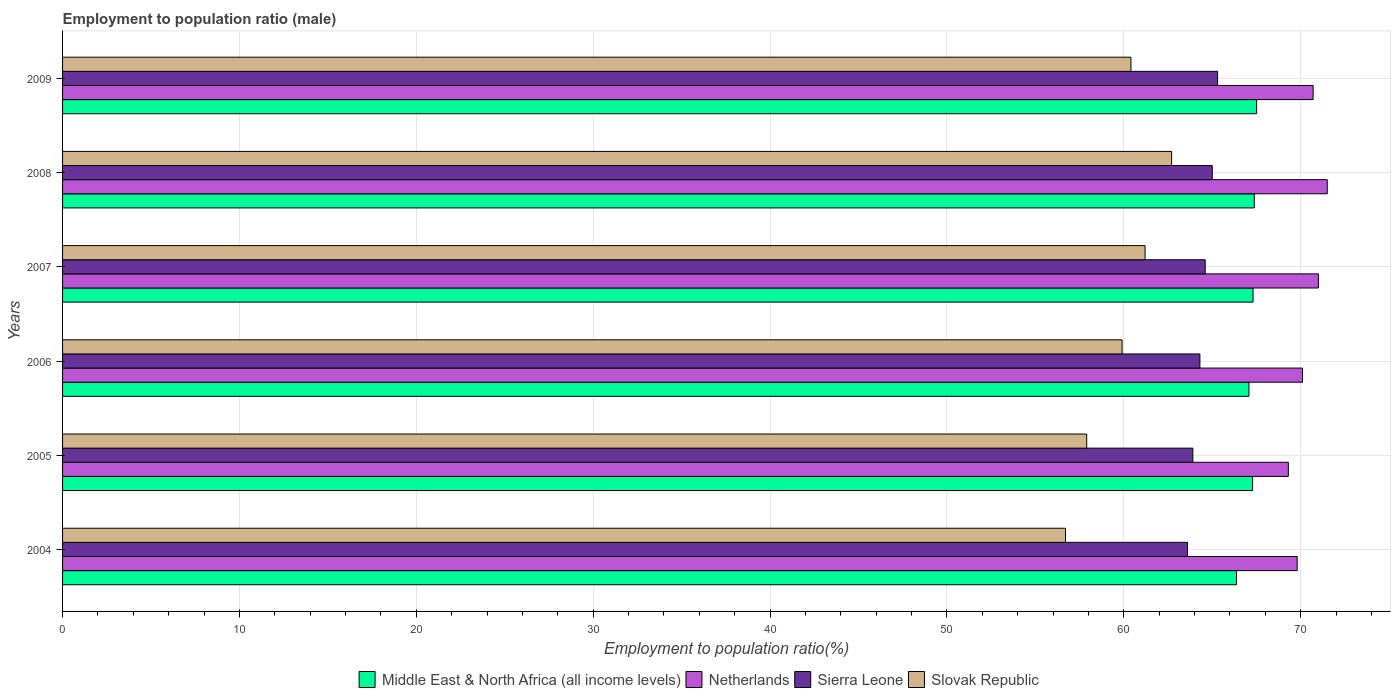How many groups of bars are there?
Offer a very short reply. 6. Are the number of bars on each tick of the Y-axis equal?
Your answer should be very brief. Yes. How many bars are there on the 2nd tick from the bottom?
Provide a short and direct response. 4. What is the label of the 6th group of bars from the top?
Give a very brief answer. 2004. What is the employment to population ratio in Middle East & North Africa (all income levels) in 2009?
Provide a succinct answer. 67.51. Across all years, what is the maximum employment to population ratio in Middle East & North Africa (all income levels)?
Your answer should be compact. 67.51. Across all years, what is the minimum employment to population ratio in Netherlands?
Offer a very short reply. 69.3. In which year was the employment to population ratio in Netherlands maximum?
Offer a very short reply. 2008. What is the total employment to population ratio in Slovak Republic in the graph?
Provide a short and direct response. 358.8. What is the difference between the employment to population ratio in Netherlands in 2005 and that in 2008?
Provide a short and direct response. -2.2. What is the difference between the employment to population ratio in Netherlands in 2009 and the employment to population ratio in Slovak Republic in 2008?
Make the answer very short. 8. What is the average employment to population ratio in Netherlands per year?
Ensure brevity in your answer.  70.4. In the year 2005, what is the difference between the employment to population ratio in Slovak Republic and employment to population ratio in Sierra Leone?
Offer a very short reply. -6. In how many years, is the employment to population ratio in Slovak Republic greater than 70 %?
Offer a very short reply. 0. What is the ratio of the employment to population ratio in Slovak Republic in 2005 to that in 2008?
Provide a short and direct response. 0.92. Is the difference between the employment to population ratio in Slovak Republic in 2007 and 2008 greater than the difference between the employment to population ratio in Sierra Leone in 2007 and 2008?
Give a very brief answer. No. What is the difference between the highest and the second highest employment to population ratio in Sierra Leone?
Your answer should be compact. 0.3. What is the difference between the highest and the lowest employment to population ratio in Slovak Republic?
Provide a succinct answer. 6. What does the 1st bar from the bottom in 2009 represents?
Give a very brief answer. Middle East & North Africa (all income levels). How many years are there in the graph?
Ensure brevity in your answer.  6. What is the difference between two consecutive major ticks on the X-axis?
Your answer should be very brief. 10. Are the values on the major ticks of X-axis written in scientific E-notation?
Your answer should be compact. No. Where does the legend appear in the graph?
Your answer should be compact. Bottom center. How are the legend labels stacked?
Your answer should be very brief. Horizontal. What is the title of the graph?
Ensure brevity in your answer.  Employment to population ratio (male). Does "South Asia" appear as one of the legend labels in the graph?
Your answer should be compact. No. What is the label or title of the X-axis?
Give a very brief answer. Employment to population ratio(%). What is the label or title of the Y-axis?
Provide a short and direct response. Years. What is the Employment to population ratio(%) in Middle East & North Africa (all income levels) in 2004?
Ensure brevity in your answer.  66.37. What is the Employment to population ratio(%) of Netherlands in 2004?
Your answer should be very brief. 69.8. What is the Employment to population ratio(%) in Sierra Leone in 2004?
Provide a succinct answer. 63.6. What is the Employment to population ratio(%) of Slovak Republic in 2004?
Give a very brief answer. 56.7. What is the Employment to population ratio(%) in Middle East & North Africa (all income levels) in 2005?
Ensure brevity in your answer.  67.28. What is the Employment to population ratio(%) in Netherlands in 2005?
Keep it short and to the point. 69.3. What is the Employment to population ratio(%) of Sierra Leone in 2005?
Your answer should be very brief. 63.9. What is the Employment to population ratio(%) in Slovak Republic in 2005?
Your answer should be compact. 57.9. What is the Employment to population ratio(%) in Middle East & North Africa (all income levels) in 2006?
Your answer should be very brief. 67.07. What is the Employment to population ratio(%) of Netherlands in 2006?
Offer a terse response. 70.1. What is the Employment to population ratio(%) in Sierra Leone in 2006?
Your answer should be very brief. 64.3. What is the Employment to population ratio(%) of Slovak Republic in 2006?
Ensure brevity in your answer.  59.9. What is the Employment to population ratio(%) in Middle East & North Africa (all income levels) in 2007?
Provide a short and direct response. 67.3. What is the Employment to population ratio(%) of Sierra Leone in 2007?
Your answer should be compact. 64.6. What is the Employment to population ratio(%) of Slovak Republic in 2007?
Provide a short and direct response. 61.2. What is the Employment to population ratio(%) in Middle East & North Africa (all income levels) in 2008?
Your answer should be compact. 67.37. What is the Employment to population ratio(%) of Netherlands in 2008?
Offer a very short reply. 71.5. What is the Employment to population ratio(%) in Sierra Leone in 2008?
Your response must be concise. 65. What is the Employment to population ratio(%) of Slovak Republic in 2008?
Your answer should be very brief. 62.7. What is the Employment to population ratio(%) of Middle East & North Africa (all income levels) in 2009?
Give a very brief answer. 67.51. What is the Employment to population ratio(%) of Netherlands in 2009?
Give a very brief answer. 70.7. What is the Employment to population ratio(%) of Sierra Leone in 2009?
Keep it short and to the point. 65.3. What is the Employment to population ratio(%) of Slovak Republic in 2009?
Provide a short and direct response. 60.4. Across all years, what is the maximum Employment to population ratio(%) of Middle East & North Africa (all income levels)?
Your answer should be compact. 67.51. Across all years, what is the maximum Employment to population ratio(%) of Netherlands?
Your response must be concise. 71.5. Across all years, what is the maximum Employment to population ratio(%) of Sierra Leone?
Ensure brevity in your answer.  65.3. Across all years, what is the maximum Employment to population ratio(%) of Slovak Republic?
Your answer should be very brief. 62.7. Across all years, what is the minimum Employment to population ratio(%) of Middle East & North Africa (all income levels)?
Keep it short and to the point. 66.37. Across all years, what is the minimum Employment to population ratio(%) in Netherlands?
Make the answer very short. 69.3. Across all years, what is the minimum Employment to population ratio(%) of Sierra Leone?
Your answer should be very brief. 63.6. Across all years, what is the minimum Employment to population ratio(%) in Slovak Republic?
Provide a succinct answer. 56.7. What is the total Employment to population ratio(%) in Middle East & North Africa (all income levels) in the graph?
Offer a terse response. 402.9. What is the total Employment to population ratio(%) in Netherlands in the graph?
Make the answer very short. 422.4. What is the total Employment to population ratio(%) in Sierra Leone in the graph?
Your response must be concise. 386.7. What is the total Employment to population ratio(%) in Slovak Republic in the graph?
Make the answer very short. 358.8. What is the difference between the Employment to population ratio(%) of Middle East & North Africa (all income levels) in 2004 and that in 2005?
Keep it short and to the point. -0.91. What is the difference between the Employment to population ratio(%) in Sierra Leone in 2004 and that in 2005?
Give a very brief answer. -0.3. What is the difference between the Employment to population ratio(%) in Middle East & North Africa (all income levels) in 2004 and that in 2006?
Offer a terse response. -0.71. What is the difference between the Employment to population ratio(%) of Netherlands in 2004 and that in 2006?
Give a very brief answer. -0.3. What is the difference between the Employment to population ratio(%) of Sierra Leone in 2004 and that in 2006?
Offer a terse response. -0.7. What is the difference between the Employment to population ratio(%) in Slovak Republic in 2004 and that in 2006?
Your answer should be compact. -3.2. What is the difference between the Employment to population ratio(%) of Middle East & North Africa (all income levels) in 2004 and that in 2007?
Give a very brief answer. -0.94. What is the difference between the Employment to population ratio(%) of Netherlands in 2004 and that in 2007?
Your response must be concise. -1.2. What is the difference between the Employment to population ratio(%) in Slovak Republic in 2004 and that in 2007?
Give a very brief answer. -4.5. What is the difference between the Employment to population ratio(%) in Middle East & North Africa (all income levels) in 2004 and that in 2008?
Offer a terse response. -1.01. What is the difference between the Employment to population ratio(%) of Netherlands in 2004 and that in 2008?
Offer a terse response. -1.7. What is the difference between the Employment to population ratio(%) of Sierra Leone in 2004 and that in 2008?
Give a very brief answer. -1.4. What is the difference between the Employment to population ratio(%) in Slovak Republic in 2004 and that in 2008?
Offer a terse response. -6. What is the difference between the Employment to population ratio(%) of Middle East & North Africa (all income levels) in 2004 and that in 2009?
Provide a short and direct response. -1.14. What is the difference between the Employment to population ratio(%) in Netherlands in 2004 and that in 2009?
Your response must be concise. -0.9. What is the difference between the Employment to population ratio(%) in Sierra Leone in 2004 and that in 2009?
Your response must be concise. -1.7. What is the difference between the Employment to population ratio(%) of Middle East & North Africa (all income levels) in 2005 and that in 2006?
Provide a short and direct response. 0.21. What is the difference between the Employment to population ratio(%) in Middle East & North Africa (all income levels) in 2005 and that in 2007?
Give a very brief answer. -0.03. What is the difference between the Employment to population ratio(%) of Slovak Republic in 2005 and that in 2007?
Offer a very short reply. -3.3. What is the difference between the Employment to population ratio(%) of Middle East & North Africa (all income levels) in 2005 and that in 2008?
Provide a succinct answer. -0.09. What is the difference between the Employment to population ratio(%) in Netherlands in 2005 and that in 2008?
Provide a short and direct response. -2.2. What is the difference between the Employment to population ratio(%) of Middle East & North Africa (all income levels) in 2005 and that in 2009?
Your response must be concise. -0.23. What is the difference between the Employment to population ratio(%) of Netherlands in 2005 and that in 2009?
Give a very brief answer. -1.4. What is the difference between the Employment to population ratio(%) in Middle East & North Africa (all income levels) in 2006 and that in 2007?
Your answer should be compact. -0.23. What is the difference between the Employment to population ratio(%) of Middle East & North Africa (all income levels) in 2006 and that in 2008?
Offer a terse response. -0.3. What is the difference between the Employment to population ratio(%) in Sierra Leone in 2006 and that in 2008?
Provide a short and direct response. -0.7. What is the difference between the Employment to population ratio(%) in Middle East & North Africa (all income levels) in 2006 and that in 2009?
Make the answer very short. -0.43. What is the difference between the Employment to population ratio(%) of Netherlands in 2006 and that in 2009?
Keep it short and to the point. -0.6. What is the difference between the Employment to population ratio(%) in Sierra Leone in 2006 and that in 2009?
Your answer should be compact. -1. What is the difference between the Employment to population ratio(%) in Middle East & North Africa (all income levels) in 2007 and that in 2008?
Offer a terse response. -0.07. What is the difference between the Employment to population ratio(%) in Sierra Leone in 2007 and that in 2008?
Your response must be concise. -0.4. What is the difference between the Employment to population ratio(%) in Slovak Republic in 2007 and that in 2008?
Keep it short and to the point. -1.5. What is the difference between the Employment to population ratio(%) of Middle East & North Africa (all income levels) in 2007 and that in 2009?
Your answer should be very brief. -0.2. What is the difference between the Employment to population ratio(%) in Netherlands in 2007 and that in 2009?
Provide a short and direct response. 0.3. What is the difference between the Employment to population ratio(%) of Sierra Leone in 2007 and that in 2009?
Provide a short and direct response. -0.7. What is the difference between the Employment to population ratio(%) in Slovak Republic in 2007 and that in 2009?
Provide a succinct answer. 0.8. What is the difference between the Employment to population ratio(%) of Middle East & North Africa (all income levels) in 2008 and that in 2009?
Keep it short and to the point. -0.13. What is the difference between the Employment to population ratio(%) in Middle East & North Africa (all income levels) in 2004 and the Employment to population ratio(%) in Netherlands in 2005?
Provide a succinct answer. -2.93. What is the difference between the Employment to population ratio(%) in Middle East & North Africa (all income levels) in 2004 and the Employment to population ratio(%) in Sierra Leone in 2005?
Your answer should be compact. 2.47. What is the difference between the Employment to population ratio(%) in Middle East & North Africa (all income levels) in 2004 and the Employment to population ratio(%) in Slovak Republic in 2005?
Provide a succinct answer. 8.47. What is the difference between the Employment to population ratio(%) in Netherlands in 2004 and the Employment to population ratio(%) in Sierra Leone in 2005?
Offer a very short reply. 5.9. What is the difference between the Employment to population ratio(%) of Netherlands in 2004 and the Employment to population ratio(%) of Slovak Republic in 2005?
Keep it short and to the point. 11.9. What is the difference between the Employment to population ratio(%) in Sierra Leone in 2004 and the Employment to population ratio(%) in Slovak Republic in 2005?
Make the answer very short. 5.7. What is the difference between the Employment to population ratio(%) of Middle East & North Africa (all income levels) in 2004 and the Employment to population ratio(%) of Netherlands in 2006?
Offer a terse response. -3.73. What is the difference between the Employment to population ratio(%) of Middle East & North Africa (all income levels) in 2004 and the Employment to population ratio(%) of Sierra Leone in 2006?
Keep it short and to the point. 2.07. What is the difference between the Employment to population ratio(%) of Middle East & North Africa (all income levels) in 2004 and the Employment to population ratio(%) of Slovak Republic in 2006?
Your answer should be very brief. 6.47. What is the difference between the Employment to population ratio(%) of Netherlands in 2004 and the Employment to population ratio(%) of Sierra Leone in 2006?
Your answer should be compact. 5.5. What is the difference between the Employment to population ratio(%) in Middle East & North Africa (all income levels) in 2004 and the Employment to population ratio(%) in Netherlands in 2007?
Keep it short and to the point. -4.63. What is the difference between the Employment to population ratio(%) of Middle East & North Africa (all income levels) in 2004 and the Employment to population ratio(%) of Sierra Leone in 2007?
Provide a succinct answer. 1.77. What is the difference between the Employment to population ratio(%) of Middle East & North Africa (all income levels) in 2004 and the Employment to population ratio(%) of Slovak Republic in 2007?
Ensure brevity in your answer.  5.17. What is the difference between the Employment to population ratio(%) of Sierra Leone in 2004 and the Employment to population ratio(%) of Slovak Republic in 2007?
Make the answer very short. 2.4. What is the difference between the Employment to population ratio(%) of Middle East & North Africa (all income levels) in 2004 and the Employment to population ratio(%) of Netherlands in 2008?
Make the answer very short. -5.13. What is the difference between the Employment to population ratio(%) of Middle East & North Africa (all income levels) in 2004 and the Employment to population ratio(%) of Sierra Leone in 2008?
Provide a succinct answer. 1.37. What is the difference between the Employment to population ratio(%) in Middle East & North Africa (all income levels) in 2004 and the Employment to population ratio(%) in Slovak Republic in 2008?
Ensure brevity in your answer.  3.67. What is the difference between the Employment to population ratio(%) of Sierra Leone in 2004 and the Employment to population ratio(%) of Slovak Republic in 2008?
Your answer should be compact. 0.9. What is the difference between the Employment to population ratio(%) of Middle East & North Africa (all income levels) in 2004 and the Employment to population ratio(%) of Netherlands in 2009?
Keep it short and to the point. -4.33. What is the difference between the Employment to population ratio(%) of Middle East & North Africa (all income levels) in 2004 and the Employment to population ratio(%) of Sierra Leone in 2009?
Offer a very short reply. 1.07. What is the difference between the Employment to population ratio(%) in Middle East & North Africa (all income levels) in 2004 and the Employment to population ratio(%) in Slovak Republic in 2009?
Offer a very short reply. 5.97. What is the difference between the Employment to population ratio(%) in Netherlands in 2004 and the Employment to population ratio(%) in Sierra Leone in 2009?
Your answer should be very brief. 4.5. What is the difference between the Employment to population ratio(%) in Middle East & North Africa (all income levels) in 2005 and the Employment to population ratio(%) in Netherlands in 2006?
Provide a succinct answer. -2.82. What is the difference between the Employment to population ratio(%) of Middle East & North Africa (all income levels) in 2005 and the Employment to population ratio(%) of Sierra Leone in 2006?
Offer a very short reply. 2.98. What is the difference between the Employment to population ratio(%) in Middle East & North Africa (all income levels) in 2005 and the Employment to population ratio(%) in Slovak Republic in 2006?
Provide a succinct answer. 7.38. What is the difference between the Employment to population ratio(%) of Middle East & North Africa (all income levels) in 2005 and the Employment to population ratio(%) of Netherlands in 2007?
Your response must be concise. -3.72. What is the difference between the Employment to population ratio(%) in Middle East & North Africa (all income levels) in 2005 and the Employment to population ratio(%) in Sierra Leone in 2007?
Give a very brief answer. 2.68. What is the difference between the Employment to population ratio(%) of Middle East & North Africa (all income levels) in 2005 and the Employment to population ratio(%) of Slovak Republic in 2007?
Provide a short and direct response. 6.08. What is the difference between the Employment to population ratio(%) in Netherlands in 2005 and the Employment to population ratio(%) in Slovak Republic in 2007?
Your answer should be very brief. 8.1. What is the difference between the Employment to population ratio(%) of Middle East & North Africa (all income levels) in 2005 and the Employment to population ratio(%) of Netherlands in 2008?
Your response must be concise. -4.22. What is the difference between the Employment to population ratio(%) of Middle East & North Africa (all income levels) in 2005 and the Employment to population ratio(%) of Sierra Leone in 2008?
Give a very brief answer. 2.28. What is the difference between the Employment to population ratio(%) of Middle East & North Africa (all income levels) in 2005 and the Employment to population ratio(%) of Slovak Republic in 2008?
Provide a succinct answer. 4.58. What is the difference between the Employment to population ratio(%) in Sierra Leone in 2005 and the Employment to population ratio(%) in Slovak Republic in 2008?
Offer a terse response. 1.2. What is the difference between the Employment to population ratio(%) in Middle East & North Africa (all income levels) in 2005 and the Employment to population ratio(%) in Netherlands in 2009?
Your answer should be compact. -3.42. What is the difference between the Employment to population ratio(%) in Middle East & North Africa (all income levels) in 2005 and the Employment to population ratio(%) in Sierra Leone in 2009?
Your response must be concise. 1.98. What is the difference between the Employment to population ratio(%) of Middle East & North Africa (all income levels) in 2005 and the Employment to population ratio(%) of Slovak Republic in 2009?
Give a very brief answer. 6.88. What is the difference between the Employment to population ratio(%) in Netherlands in 2005 and the Employment to population ratio(%) in Sierra Leone in 2009?
Your answer should be very brief. 4. What is the difference between the Employment to population ratio(%) in Middle East & North Africa (all income levels) in 2006 and the Employment to population ratio(%) in Netherlands in 2007?
Make the answer very short. -3.93. What is the difference between the Employment to population ratio(%) in Middle East & North Africa (all income levels) in 2006 and the Employment to population ratio(%) in Sierra Leone in 2007?
Provide a succinct answer. 2.47. What is the difference between the Employment to population ratio(%) in Middle East & North Africa (all income levels) in 2006 and the Employment to population ratio(%) in Slovak Republic in 2007?
Provide a short and direct response. 5.87. What is the difference between the Employment to population ratio(%) of Netherlands in 2006 and the Employment to population ratio(%) of Slovak Republic in 2007?
Your answer should be very brief. 8.9. What is the difference between the Employment to population ratio(%) in Sierra Leone in 2006 and the Employment to population ratio(%) in Slovak Republic in 2007?
Make the answer very short. 3.1. What is the difference between the Employment to population ratio(%) of Middle East & North Africa (all income levels) in 2006 and the Employment to population ratio(%) of Netherlands in 2008?
Give a very brief answer. -4.43. What is the difference between the Employment to population ratio(%) of Middle East & North Africa (all income levels) in 2006 and the Employment to population ratio(%) of Sierra Leone in 2008?
Provide a succinct answer. 2.07. What is the difference between the Employment to population ratio(%) of Middle East & North Africa (all income levels) in 2006 and the Employment to population ratio(%) of Slovak Republic in 2008?
Provide a short and direct response. 4.37. What is the difference between the Employment to population ratio(%) in Netherlands in 2006 and the Employment to population ratio(%) in Slovak Republic in 2008?
Your response must be concise. 7.4. What is the difference between the Employment to population ratio(%) in Middle East & North Africa (all income levels) in 2006 and the Employment to population ratio(%) in Netherlands in 2009?
Give a very brief answer. -3.63. What is the difference between the Employment to population ratio(%) in Middle East & North Africa (all income levels) in 2006 and the Employment to population ratio(%) in Sierra Leone in 2009?
Give a very brief answer. 1.77. What is the difference between the Employment to population ratio(%) in Middle East & North Africa (all income levels) in 2006 and the Employment to population ratio(%) in Slovak Republic in 2009?
Offer a very short reply. 6.67. What is the difference between the Employment to population ratio(%) in Netherlands in 2006 and the Employment to population ratio(%) in Sierra Leone in 2009?
Make the answer very short. 4.8. What is the difference between the Employment to population ratio(%) of Middle East & North Africa (all income levels) in 2007 and the Employment to population ratio(%) of Netherlands in 2008?
Ensure brevity in your answer.  -4.2. What is the difference between the Employment to population ratio(%) in Middle East & North Africa (all income levels) in 2007 and the Employment to population ratio(%) in Sierra Leone in 2008?
Offer a very short reply. 2.3. What is the difference between the Employment to population ratio(%) of Middle East & North Africa (all income levels) in 2007 and the Employment to population ratio(%) of Slovak Republic in 2008?
Provide a succinct answer. 4.6. What is the difference between the Employment to population ratio(%) of Sierra Leone in 2007 and the Employment to population ratio(%) of Slovak Republic in 2008?
Give a very brief answer. 1.9. What is the difference between the Employment to population ratio(%) of Middle East & North Africa (all income levels) in 2007 and the Employment to population ratio(%) of Netherlands in 2009?
Your answer should be compact. -3.4. What is the difference between the Employment to population ratio(%) in Middle East & North Africa (all income levels) in 2007 and the Employment to population ratio(%) in Sierra Leone in 2009?
Your response must be concise. 2. What is the difference between the Employment to population ratio(%) of Middle East & North Africa (all income levels) in 2007 and the Employment to population ratio(%) of Slovak Republic in 2009?
Your answer should be very brief. 6.9. What is the difference between the Employment to population ratio(%) in Netherlands in 2007 and the Employment to population ratio(%) in Sierra Leone in 2009?
Offer a very short reply. 5.7. What is the difference between the Employment to population ratio(%) in Netherlands in 2007 and the Employment to population ratio(%) in Slovak Republic in 2009?
Give a very brief answer. 10.6. What is the difference between the Employment to population ratio(%) in Middle East & North Africa (all income levels) in 2008 and the Employment to population ratio(%) in Netherlands in 2009?
Ensure brevity in your answer.  -3.33. What is the difference between the Employment to population ratio(%) of Middle East & North Africa (all income levels) in 2008 and the Employment to population ratio(%) of Sierra Leone in 2009?
Keep it short and to the point. 2.07. What is the difference between the Employment to population ratio(%) in Middle East & North Africa (all income levels) in 2008 and the Employment to population ratio(%) in Slovak Republic in 2009?
Keep it short and to the point. 6.97. What is the difference between the Employment to population ratio(%) of Netherlands in 2008 and the Employment to population ratio(%) of Slovak Republic in 2009?
Provide a succinct answer. 11.1. What is the difference between the Employment to population ratio(%) in Sierra Leone in 2008 and the Employment to population ratio(%) in Slovak Republic in 2009?
Offer a very short reply. 4.6. What is the average Employment to population ratio(%) of Middle East & North Africa (all income levels) per year?
Offer a terse response. 67.15. What is the average Employment to population ratio(%) of Netherlands per year?
Give a very brief answer. 70.4. What is the average Employment to population ratio(%) in Sierra Leone per year?
Your response must be concise. 64.45. What is the average Employment to population ratio(%) in Slovak Republic per year?
Offer a very short reply. 59.8. In the year 2004, what is the difference between the Employment to population ratio(%) of Middle East & North Africa (all income levels) and Employment to population ratio(%) of Netherlands?
Your response must be concise. -3.43. In the year 2004, what is the difference between the Employment to population ratio(%) in Middle East & North Africa (all income levels) and Employment to population ratio(%) in Sierra Leone?
Your answer should be very brief. 2.77. In the year 2004, what is the difference between the Employment to population ratio(%) of Middle East & North Africa (all income levels) and Employment to population ratio(%) of Slovak Republic?
Your response must be concise. 9.67. In the year 2004, what is the difference between the Employment to population ratio(%) of Netherlands and Employment to population ratio(%) of Slovak Republic?
Give a very brief answer. 13.1. In the year 2005, what is the difference between the Employment to population ratio(%) of Middle East & North Africa (all income levels) and Employment to population ratio(%) of Netherlands?
Your response must be concise. -2.02. In the year 2005, what is the difference between the Employment to population ratio(%) of Middle East & North Africa (all income levels) and Employment to population ratio(%) of Sierra Leone?
Your answer should be compact. 3.38. In the year 2005, what is the difference between the Employment to population ratio(%) of Middle East & North Africa (all income levels) and Employment to population ratio(%) of Slovak Republic?
Give a very brief answer. 9.38. In the year 2005, what is the difference between the Employment to population ratio(%) of Netherlands and Employment to population ratio(%) of Sierra Leone?
Provide a short and direct response. 5.4. In the year 2005, what is the difference between the Employment to population ratio(%) of Sierra Leone and Employment to population ratio(%) of Slovak Republic?
Offer a terse response. 6. In the year 2006, what is the difference between the Employment to population ratio(%) of Middle East & North Africa (all income levels) and Employment to population ratio(%) of Netherlands?
Your response must be concise. -3.03. In the year 2006, what is the difference between the Employment to population ratio(%) of Middle East & North Africa (all income levels) and Employment to population ratio(%) of Sierra Leone?
Provide a short and direct response. 2.77. In the year 2006, what is the difference between the Employment to population ratio(%) in Middle East & North Africa (all income levels) and Employment to population ratio(%) in Slovak Republic?
Provide a short and direct response. 7.17. In the year 2006, what is the difference between the Employment to population ratio(%) in Netherlands and Employment to population ratio(%) in Slovak Republic?
Keep it short and to the point. 10.2. In the year 2007, what is the difference between the Employment to population ratio(%) in Middle East & North Africa (all income levels) and Employment to population ratio(%) in Netherlands?
Provide a short and direct response. -3.7. In the year 2007, what is the difference between the Employment to population ratio(%) in Middle East & North Africa (all income levels) and Employment to population ratio(%) in Sierra Leone?
Your answer should be very brief. 2.7. In the year 2007, what is the difference between the Employment to population ratio(%) of Middle East & North Africa (all income levels) and Employment to population ratio(%) of Slovak Republic?
Make the answer very short. 6.1. In the year 2007, what is the difference between the Employment to population ratio(%) of Netherlands and Employment to population ratio(%) of Sierra Leone?
Offer a very short reply. 6.4. In the year 2007, what is the difference between the Employment to population ratio(%) of Netherlands and Employment to population ratio(%) of Slovak Republic?
Your answer should be compact. 9.8. In the year 2007, what is the difference between the Employment to population ratio(%) in Sierra Leone and Employment to population ratio(%) in Slovak Republic?
Provide a succinct answer. 3.4. In the year 2008, what is the difference between the Employment to population ratio(%) in Middle East & North Africa (all income levels) and Employment to population ratio(%) in Netherlands?
Give a very brief answer. -4.13. In the year 2008, what is the difference between the Employment to population ratio(%) in Middle East & North Africa (all income levels) and Employment to population ratio(%) in Sierra Leone?
Give a very brief answer. 2.37. In the year 2008, what is the difference between the Employment to population ratio(%) of Middle East & North Africa (all income levels) and Employment to population ratio(%) of Slovak Republic?
Provide a succinct answer. 4.67. In the year 2008, what is the difference between the Employment to population ratio(%) in Netherlands and Employment to population ratio(%) in Sierra Leone?
Your response must be concise. 6.5. In the year 2008, what is the difference between the Employment to population ratio(%) in Netherlands and Employment to population ratio(%) in Slovak Republic?
Your answer should be compact. 8.8. In the year 2009, what is the difference between the Employment to population ratio(%) in Middle East & North Africa (all income levels) and Employment to population ratio(%) in Netherlands?
Make the answer very short. -3.19. In the year 2009, what is the difference between the Employment to population ratio(%) in Middle East & North Africa (all income levels) and Employment to population ratio(%) in Sierra Leone?
Make the answer very short. 2.21. In the year 2009, what is the difference between the Employment to population ratio(%) of Middle East & North Africa (all income levels) and Employment to population ratio(%) of Slovak Republic?
Your answer should be compact. 7.11. In the year 2009, what is the difference between the Employment to population ratio(%) of Sierra Leone and Employment to population ratio(%) of Slovak Republic?
Provide a succinct answer. 4.9. What is the ratio of the Employment to population ratio(%) in Middle East & North Africa (all income levels) in 2004 to that in 2005?
Your answer should be very brief. 0.99. What is the ratio of the Employment to population ratio(%) of Sierra Leone in 2004 to that in 2005?
Give a very brief answer. 1. What is the ratio of the Employment to population ratio(%) in Slovak Republic in 2004 to that in 2005?
Your response must be concise. 0.98. What is the ratio of the Employment to population ratio(%) in Middle East & North Africa (all income levels) in 2004 to that in 2006?
Your answer should be compact. 0.99. What is the ratio of the Employment to population ratio(%) in Netherlands in 2004 to that in 2006?
Your response must be concise. 1. What is the ratio of the Employment to population ratio(%) in Sierra Leone in 2004 to that in 2006?
Provide a succinct answer. 0.99. What is the ratio of the Employment to population ratio(%) in Slovak Republic in 2004 to that in 2006?
Your answer should be compact. 0.95. What is the ratio of the Employment to population ratio(%) in Middle East & North Africa (all income levels) in 2004 to that in 2007?
Your response must be concise. 0.99. What is the ratio of the Employment to population ratio(%) in Netherlands in 2004 to that in 2007?
Offer a very short reply. 0.98. What is the ratio of the Employment to population ratio(%) of Sierra Leone in 2004 to that in 2007?
Give a very brief answer. 0.98. What is the ratio of the Employment to population ratio(%) of Slovak Republic in 2004 to that in 2007?
Provide a succinct answer. 0.93. What is the ratio of the Employment to population ratio(%) of Middle East & North Africa (all income levels) in 2004 to that in 2008?
Provide a succinct answer. 0.99. What is the ratio of the Employment to population ratio(%) in Netherlands in 2004 to that in 2008?
Ensure brevity in your answer.  0.98. What is the ratio of the Employment to population ratio(%) of Sierra Leone in 2004 to that in 2008?
Offer a very short reply. 0.98. What is the ratio of the Employment to population ratio(%) of Slovak Republic in 2004 to that in 2008?
Offer a terse response. 0.9. What is the ratio of the Employment to population ratio(%) in Middle East & North Africa (all income levels) in 2004 to that in 2009?
Your response must be concise. 0.98. What is the ratio of the Employment to population ratio(%) in Netherlands in 2004 to that in 2009?
Your response must be concise. 0.99. What is the ratio of the Employment to population ratio(%) in Slovak Republic in 2004 to that in 2009?
Your answer should be very brief. 0.94. What is the ratio of the Employment to population ratio(%) of Netherlands in 2005 to that in 2006?
Keep it short and to the point. 0.99. What is the ratio of the Employment to population ratio(%) of Sierra Leone in 2005 to that in 2006?
Provide a succinct answer. 0.99. What is the ratio of the Employment to population ratio(%) of Slovak Republic in 2005 to that in 2006?
Your answer should be compact. 0.97. What is the ratio of the Employment to population ratio(%) in Netherlands in 2005 to that in 2007?
Ensure brevity in your answer.  0.98. What is the ratio of the Employment to population ratio(%) in Sierra Leone in 2005 to that in 2007?
Your answer should be compact. 0.99. What is the ratio of the Employment to population ratio(%) of Slovak Republic in 2005 to that in 2007?
Give a very brief answer. 0.95. What is the ratio of the Employment to population ratio(%) in Netherlands in 2005 to that in 2008?
Provide a short and direct response. 0.97. What is the ratio of the Employment to population ratio(%) in Sierra Leone in 2005 to that in 2008?
Offer a terse response. 0.98. What is the ratio of the Employment to population ratio(%) in Slovak Republic in 2005 to that in 2008?
Your answer should be very brief. 0.92. What is the ratio of the Employment to population ratio(%) of Netherlands in 2005 to that in 2009?
Make the answer very short. 0.98. What is the ratio of the Employment to population ratio(%) of Sierra Leone in 2005 to that in 2009?
Provide a succinct answer. 0.98. What is the ratio of the Employment to population ratio(%) in Slovak Republic in 2005 to that in 2009?
Ensure brevity in your answer.  0.96. What is the ratio of the Employment to population ratio(%) of Netherlands in 2006 to that in 2007?
Provide a succinct answer. 0.99. What is the ratio of the Employment to population ratio(%) in Slovak Republic in 2006 to that in 2007?
Offer a very short reply. 0.98. What is the ratio of the Employment to population ratio(%) in Netherlands in 2006 to that in 2008?
Provide a short and direct response. 0.98. What is the ratio of the Employment to population ratio(%) in Sierra Leone in 2006 to that in 2008?
Your answer should be very brief. 0.99. What is the ratio of the Employment to population ratio(%) of Slovak Republic in 2006 to that in 2008?
Provide a short and direct response. 0.96. What is the ratio of the Employment to population ratio(%) in Netherlands in 2006 to that in 2009?
Give a very brief answer. 0.99. What is the ratio of the Employment to population ratio(%) in Sierra Leone in 2006 to that in 2009?
Provide a succinct answer. 0.98. What is the ratio of the Employment to population ratio(%) of Sierra Leone in 2007 to that in 2008?
Offer a terse response. 0.99. What is the ratio of the Employment to population ratio(%) in Slovak Republic in 2007 to that in 2008?
Offer a very short reply. 0.98. What is the ratio of the Employment to population ratio(%) in Middle East & North Africa (all income levels) in 2007 to that in 2009?
Provide a succinct answer. 1. What is the ratio of the Employment to population ratio(%) in Sierra Leone in 2007 to that in 2009?
Ensure brevity in your answer.  0.99. What is the ratio of the Employment to population ratio(%) in Slovak Republic in 2007 to that in 2009?
Your answer should be very brief. 1.01. What is the ratio of the Employment to population ratio(%) in Netherlands in 2008 to that in 2009?
Provide a short and direct response. 1.01. What is the ratio of the Employment to population ratio(%) of Sierra Leone in 2008 to that in 2009?
Offer a very short reply. 1. What is the ratio of the Employment to population ratio(%) in Slovak Republic in 2008 to that in 2009?
Keep it short and to the point. 1.04. What is the difference between the highest and the second highest Employment to population ratio(%) of Middle East & North Africa (all income levels)?
Keep it short and to the point. 0.13. What is the difference between the highest and the second highest Employment to population ratio(%) of Sierra Leone?
Provide a short and direct response. 0.3. What is the difference between the highest and the second highest Employment to population ratio(%) of Slovak Republic?
Make the answer very short. 1.5. What is the difference between the highest and the lowest Employment to population ratio(%) in Middle East & North Africa (all income levels)?
Offer a terse response. 1.14. What is the difference between the highest and the lowest Employment to population ratio(%) of Netherlands?
Offer a terse response. 2.2. What is the difference between the highest and the lowest Employment to population ratio(%) of Slovak Republic?
Keep it short and to the point. 6. 